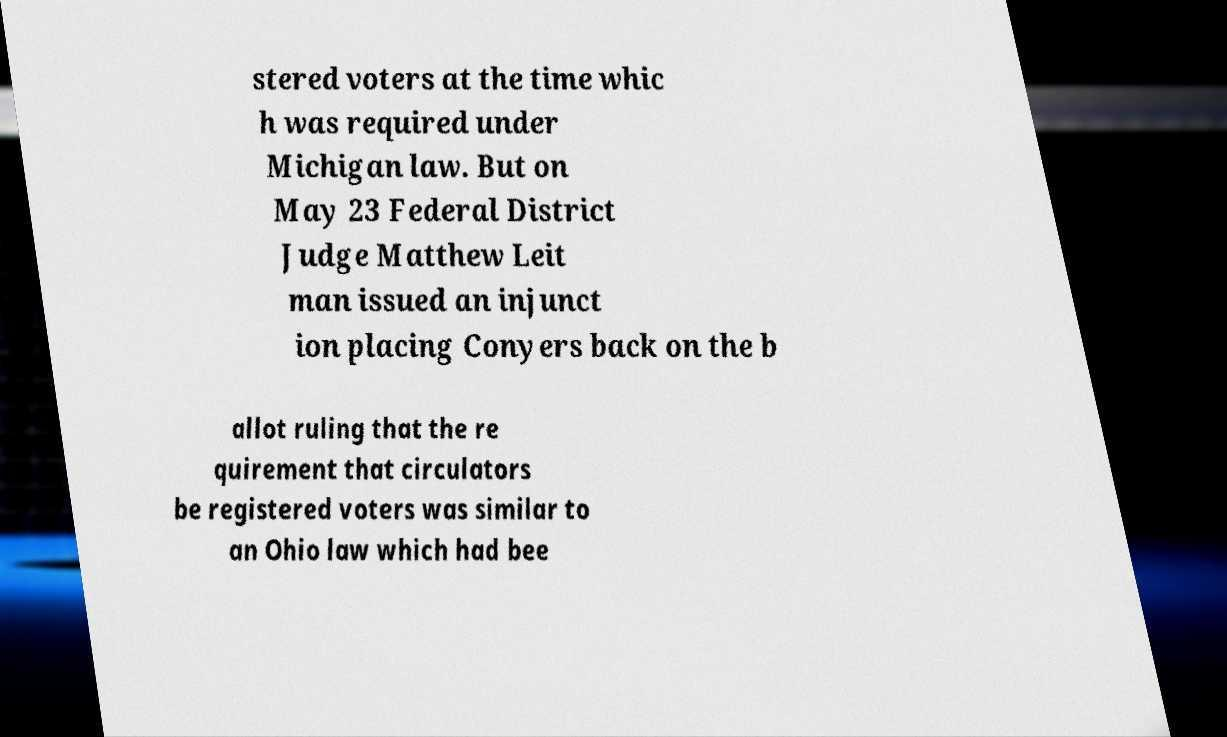What messages or text are displayed in this image? I need them in a readable, typed format. stered voters at the time whic h was required under Michigan law. But on May 23 Federal District Judge Matthew Leit man issued an injunct ion placing Conyers back on the b allot ruling that the re quirement that circulators be registered voters was similar to an Ohio law which had bee 